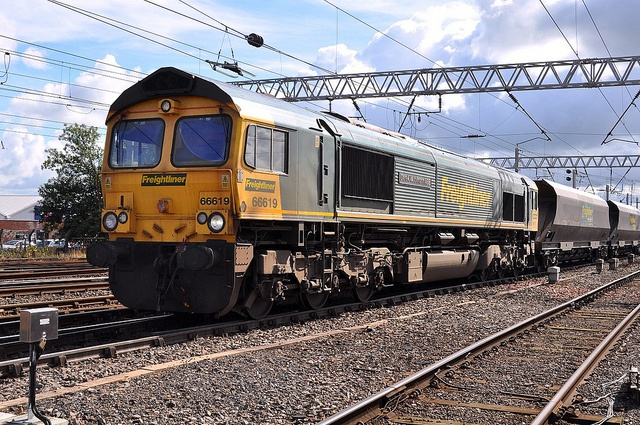Describe the objects in this image and their specific colors. I can see train in lavender, black, darkgray, lightgray, and olive tones, car in lavender, gray, darkgray, lightgray, and black tones, car in lavender, black, and gray tones, car in lavender, gray, darkgray, and black tones, and car in lavender, black, gray, maroon, and brown tones in this image. 